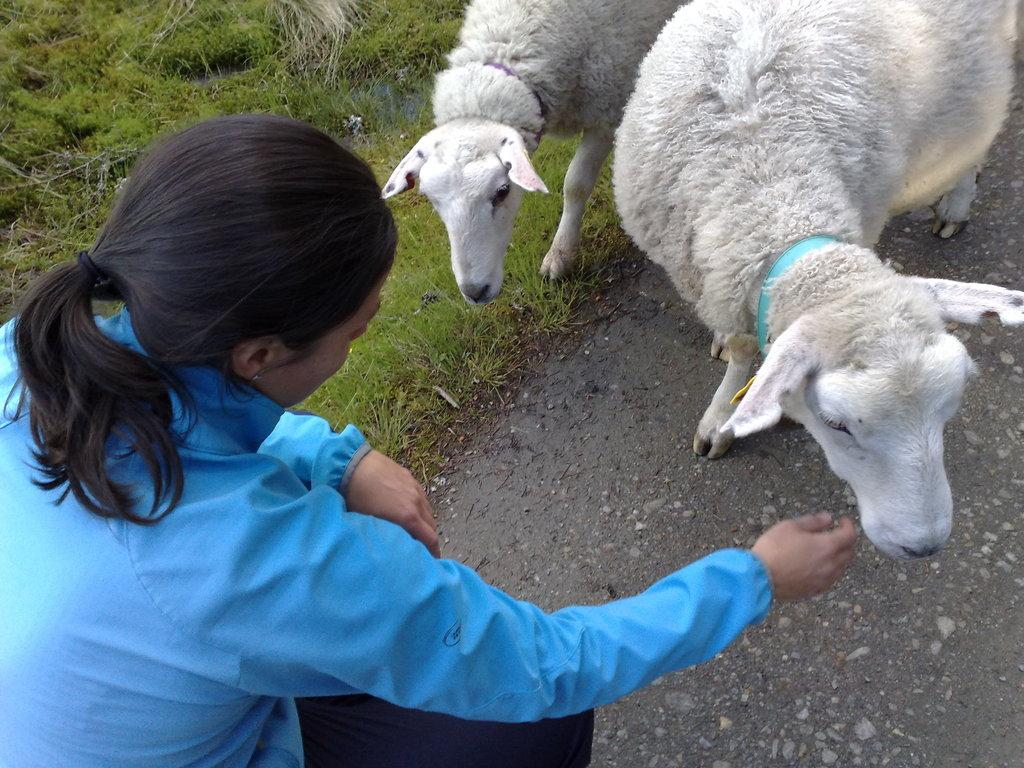What is the woman doing in the image? The woman is sitting in the image. What animals are present in the image? There are two sheep standing in the image. What type of vegetation is visible at the bottom of the image? There is grass at the bottom of the image. What man-made structure can be seen in the image? There is a road in the image. What time of day is it in the image, based on the position of the sun? There is no sun visible in the image, so it is not possible to determine the time of day based on its position. 